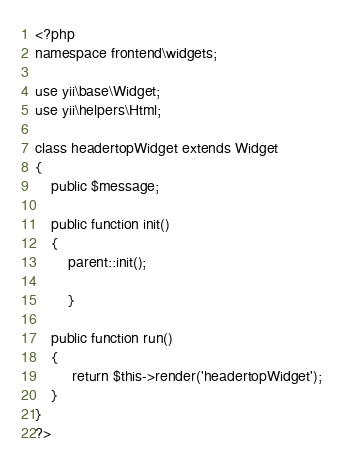<code> <loc_0><loc_0><loc_500><loc_500><_PHP_><?php 
namespace frontend\widgets;

use yii\base\Widget;
use yii\helpers\Html;

class headertopWidget extends Widget
{
    public $message;

    public function init()
    {
        parent::init();
      
        }

    public function run()
    {
         return $this->render('headertopWidget');   
    }
}
?></code> 